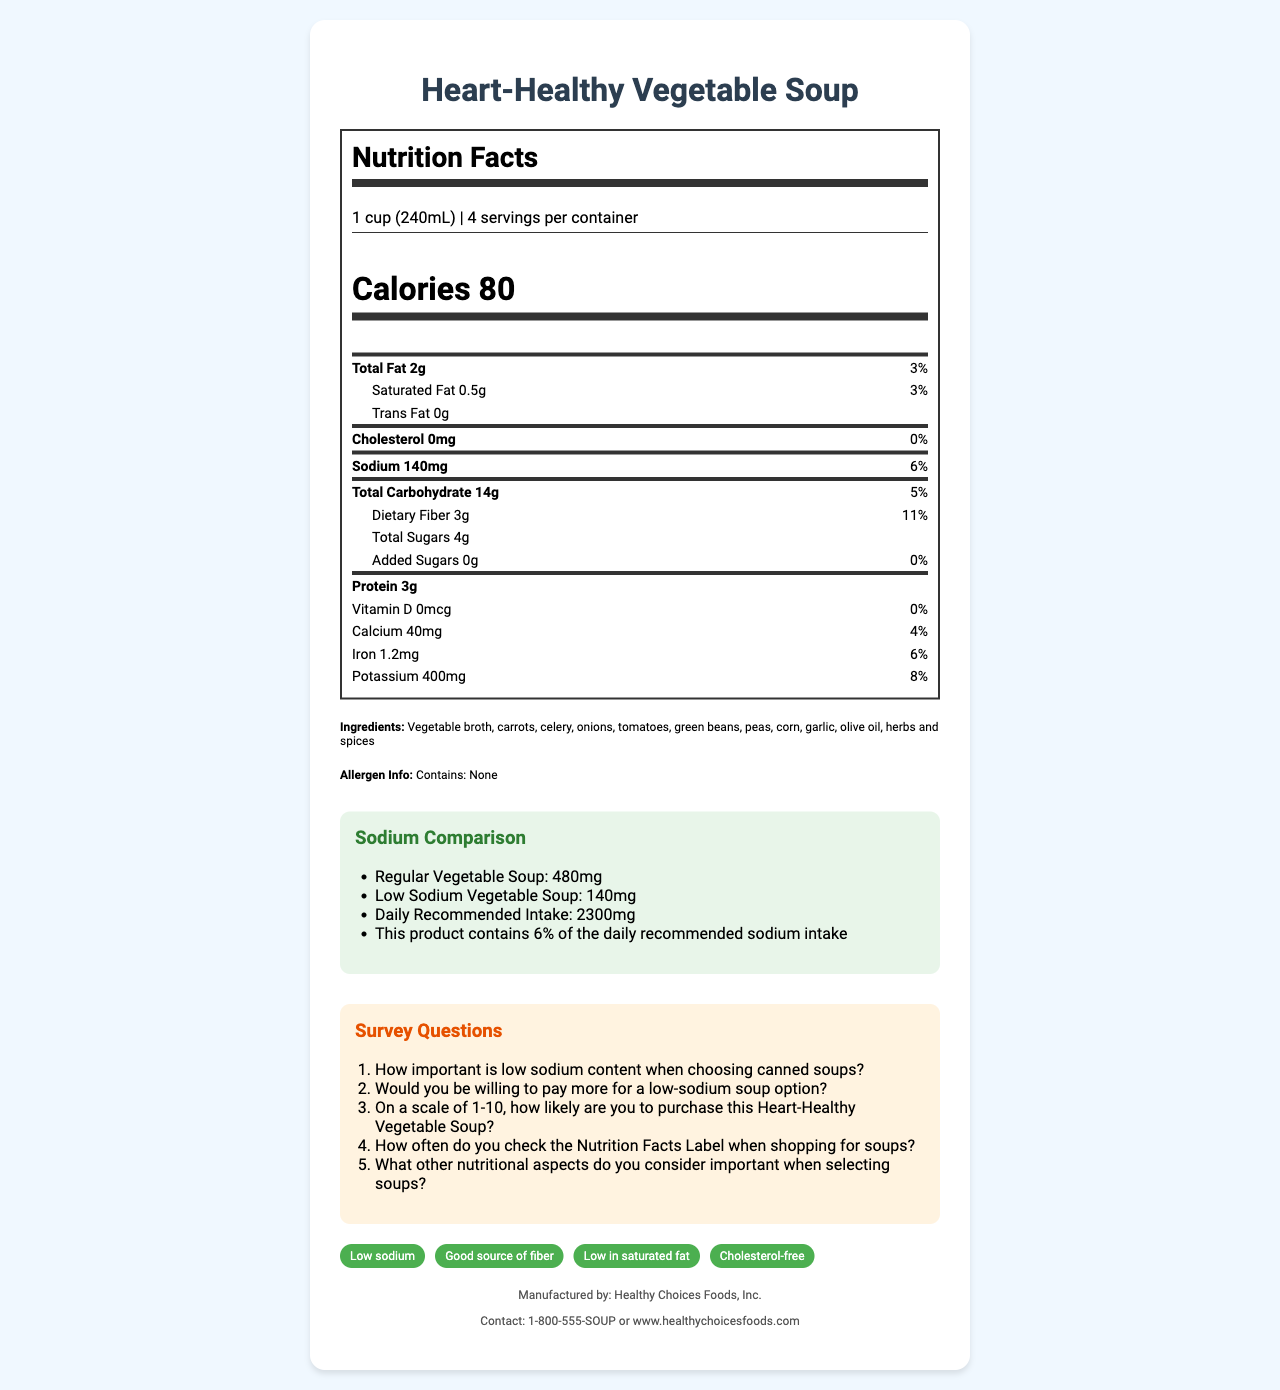what is the serving size for the Heart-Healthy Vegetable Soup? The serving size is listed as "1 cup (240mL)" towards the top of the Nutrition Facts label.
Answer: 1 cup (240mL) how many calories are in one serving of the soup? The calories per serving are listed as "80" in the large bold font within the Nutrition Facts label.
Answer: 80 what is the amount of sodium per serving? The amount of sodium is mentioned under the nutrient section as "Sodium 140mg".
Answer: 140mg how many grams of dietary fiber does the soup contain per serving? The dietary fiber amount per serving is listed as "Dietary Fiber 3g".
Answer: 3g what are the first three ingredients listed? The first three ingredients listed under the ingredients section are "Vegetable broth, carrots, celery".
Answer: Vegetable broth, carrots, celery how many servings are there per container? A. 2 B. 3 C. 4 The document states there are "4 servings per container".
Answer: C what is the daily recommended intake percentage for sodium provided by this soup? i. 3% ii. 6% iii. 11% iv. 8% The document states that the soup provides "6%" of the daily recommended intake for sodium.
Answer: ii which of the following nutrients does this soup NOT contain? A. Cholesterol B. Vitamin D C. Trans Fat D. All of the above The document shows "Cholesterol 0mg", "Vitamin D 0mcg", and "Trans Fat 0g", thus "All of the above" are not contained in the soup.
Answer: D Would you be likely to recommend this low-sodium soup to a friend or family member? (Yes/No) This would be subjective, but given its low sodium content, positive health claims, and if a user finds it meets their dietary needs.
Answer: Yes describe the main idea of this nutrition facts label. The document includes information about serving size, calories, various nutrients, ingredients, comparison of sodium content to other soups, survey questions for consumers, health claims about the product, and manufacturer contact details.
Answer: The document is describing the nutritional content of the Heart-Healthy Vegetable Soup, focusing on its low sodium content, ingredients, health claims, and survey questions for consumer feedback. It compares the soup's sodium level to both regular and low-sodium soups and lists contact information for the manufacturer. which country is this soup manufactured in? The document does not provide any details about the country of manufacturing.
Answer: Not enough information 